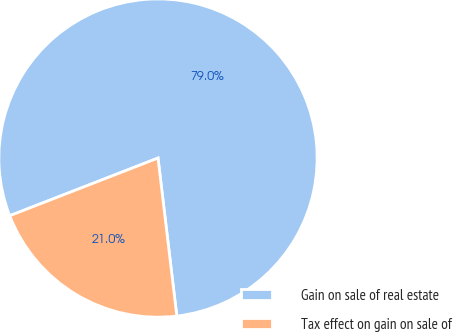Convert chart. <chart><loc_0><loc_0><loc_500><loc_500><pie_chart><fcel>Gain on sale of real estate<fcel>Tax effect on gain on sale of<nl><fcel>79.02%<fcel>20.98%<nl></chart> 